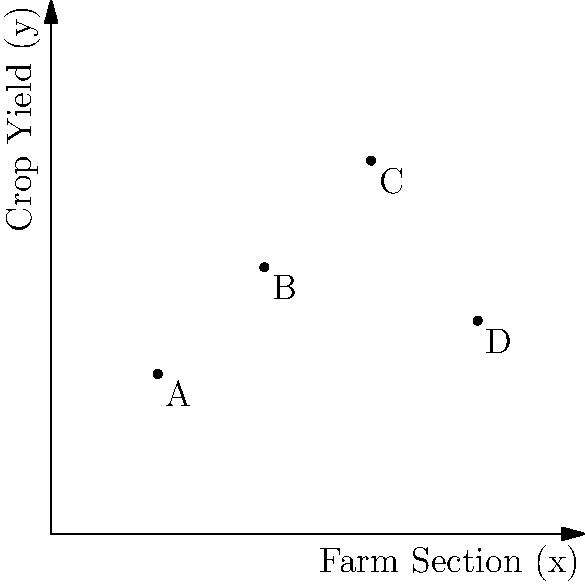Based on the scatter plot of crop yield data across different farm sections, which section shows the highest yield for the drought-resistant crop variety? To determine which farm section shows the highest yield for the drought-resistant crop variety, we need to analyze the scatter plot:

1. Identify the data points:
   A: (2, 3)
   B: (4, 5)
   C: (6, 7)
   D: (8, 4)

2. Compare the y-coordinates (crop yield) of each point:
   A: y = 3
   B: y = 5
   C: y = 7
   D: y = 4

3. Identify the highest y-coordinate:
   The highest y-coordinate is 7, corresponding to point C.

4. Determine the farm section:
   Point C has an x-coordinate of 6, representing farm section 6.

Therefore, farm section 6 shows the highest yield for the drought-resistant crop variety.
Answer: Section 6 